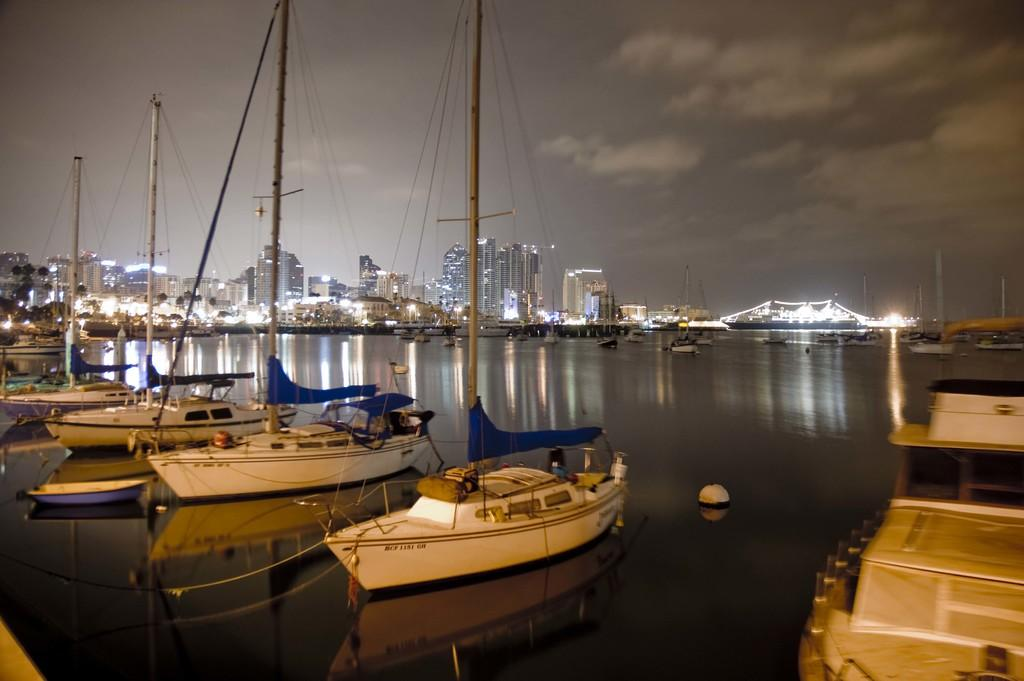What can be seen on the left side of the image? There are boats in the water on the left side of the image. What is visible in the background of the image? There are big buildings with lights in the background of the image. What is visible at the top of the image? The sky is visible at the top of the image. Where is the button located in the image? There is no button present in the image. What type of church can be seen in the image? There is no church present in the image. 